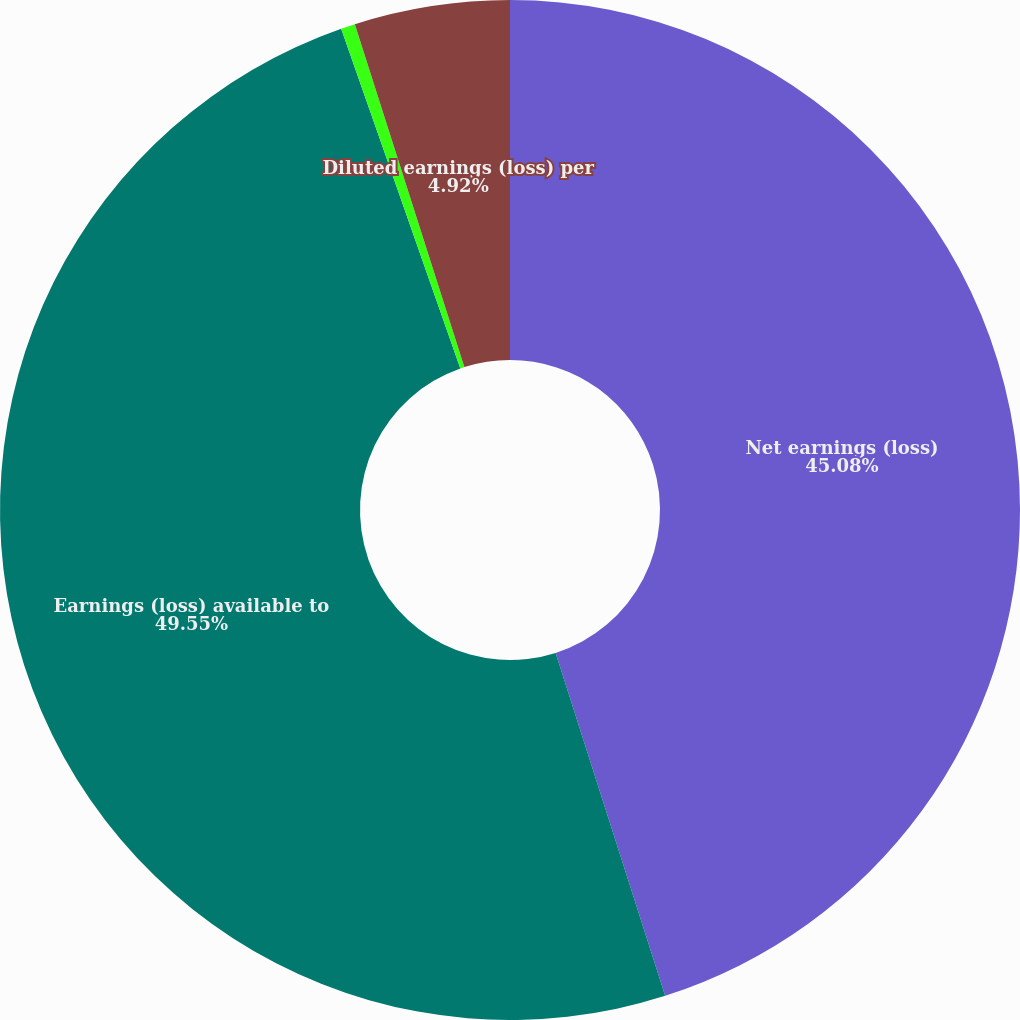Convert chart. <chart><loc_0><loc_0><loc_500><loc_500><pie_chart><fcel>Net earnings (loss)<fcel>Earnings (loss) available to<fcel>Basic earnings (loss) per<fcel>Diluted earnings (loss) per<nl><fcel>45.08%<fcel>49.55%<fcel>0.45%<fcel>4.92%<nl></chart> 